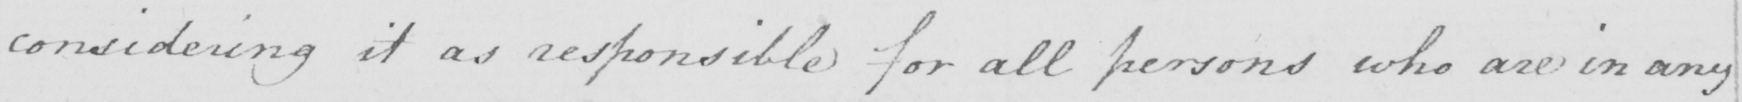Please provide the text content of this handwritten line. considering it as responsible for all persons who are in any 